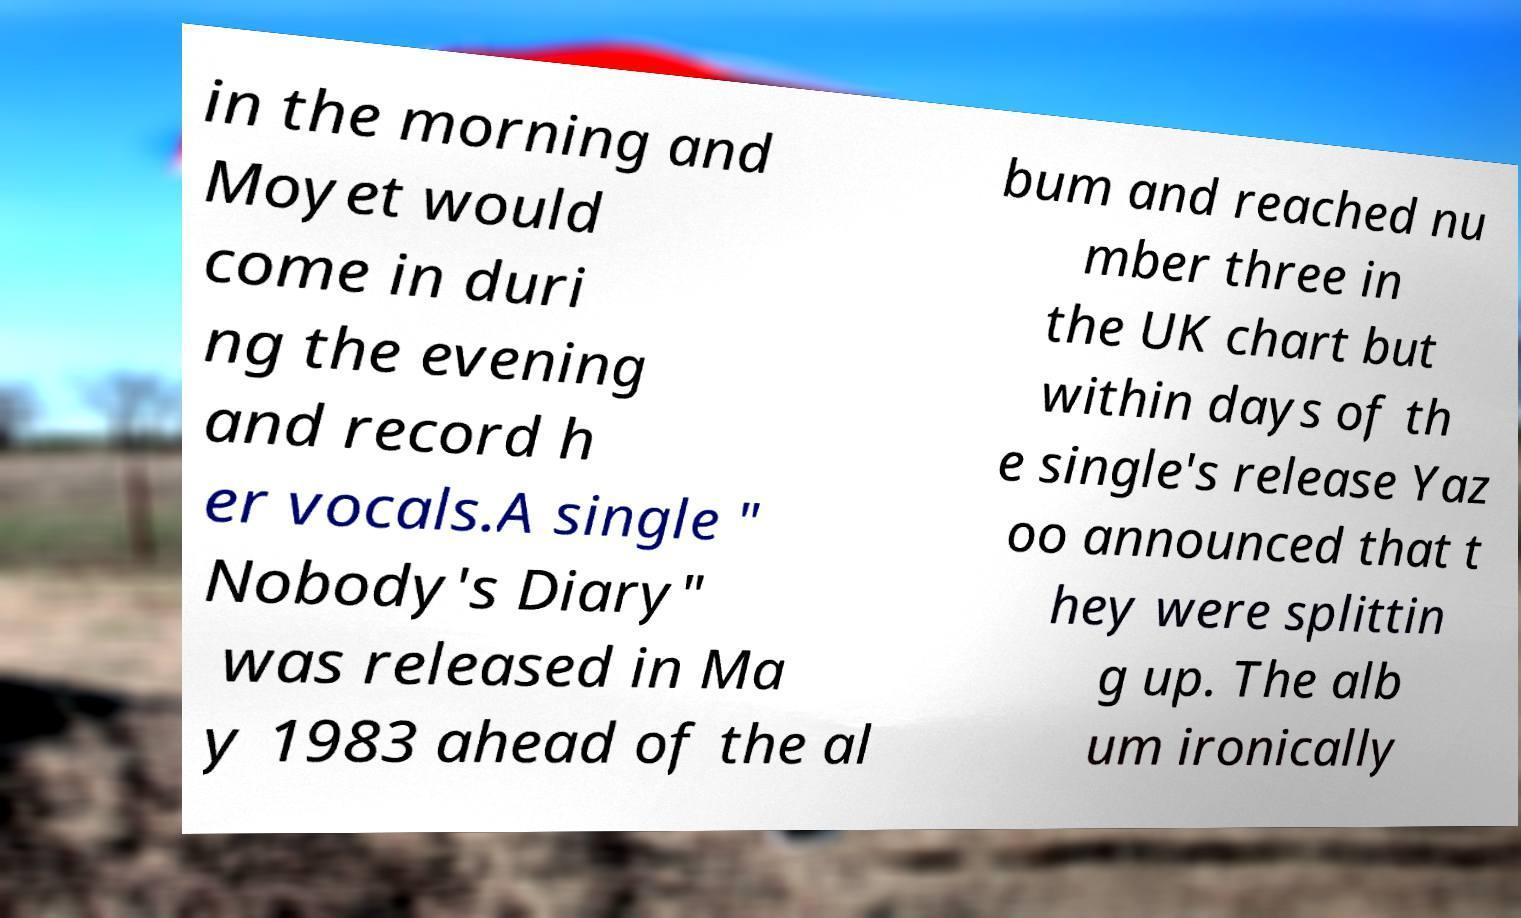There's text embedded in this image that I need extracted. Can you transcribe it verbatim? in the morning and Moyet would come in duri ng the evening and record h er vocals.A single " Nobody's Diary" was released in Ma y 1983 ahead of the al bum and reached nu mber three in the UK chart but within days of th e single's release Yaz oo announced that t hey were splittin g up. The alb um ironically 